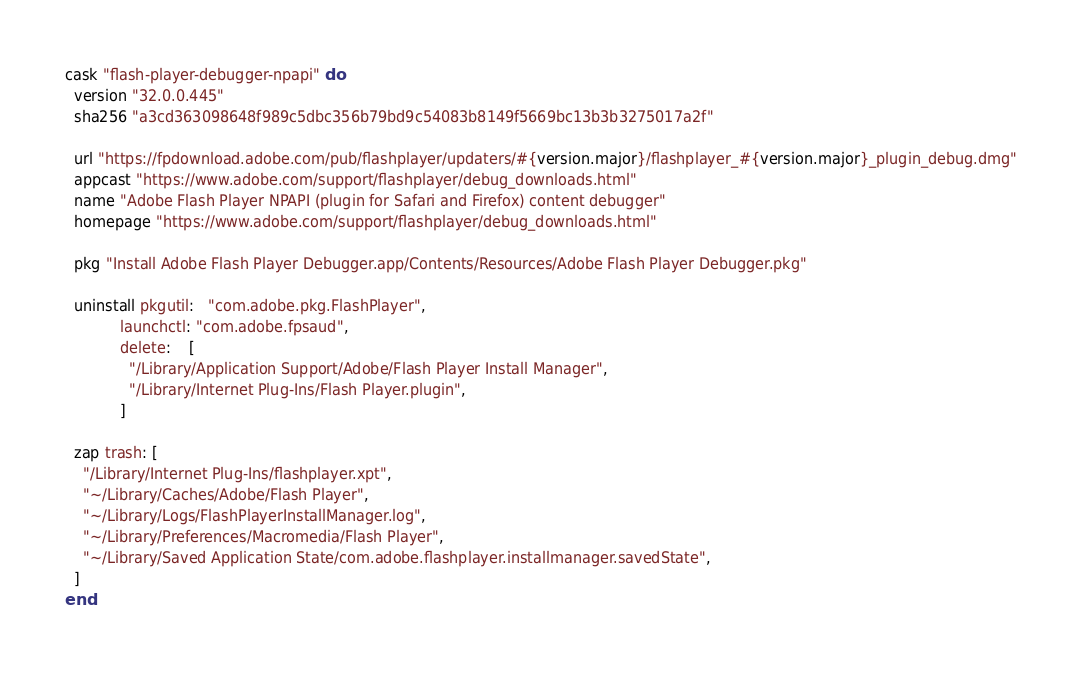Convert code to text. <code><loc_0><loc_0><loc_500><loc_500><_Ruby_>cask "flash-player-debugger-npapi" do
  version "32.0.0.445"
  sha256 "a3cd363098648f989c5dbc356b79bd9c54083b8149f5669bc13b3b3275017a2f"

  url "https://fpdownload.adobe.com/pub/flashplayer/updaters/#{version.major}/flashplayer_#{version.major}_plugin_debug.dmg"
  appcast "https://www.adobe.com/support/flashplayer/debug_downloads.html"
  name "Adobe Flash Player NPAPI (plugin for Safari and Firefox) content debugger"
  homepage "https://www.adobe.com/support/flashplayer/debug_downloads.html"

  pkg "Install Adobe Flash Player Debugger.app/Contents/Resources/Adobe Flash Player Debugger.pkg"

  uninstall pkgutil:   "com.adobe.pkg.FlashPlayer",
            launchctl: "com.adobe.fpsaud",
            delete:    [
              "/Library/Application Support/Adobe/Flash Player Install Manager",
              "/Library/Internet Plug-Ins/Flash Player.plugin",
            ]

  zap trash: [
    "/Library/Internet Plug-Ins/flashplayer.xpt",
    "~/Library/Caches/Adobe/Flash Player",
    "~/Library/Logs/FlashPlayerInstallManager.log",
    "~/Library/Preferences/Macromedia/Flash Player",
    "~/Library/Saved Application State/com.adobe.flashplayer.installmanager.savedState",
  ]
end
</code> 